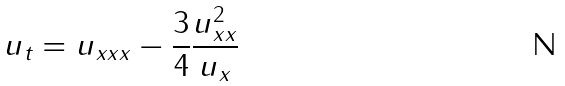Convert formula to latex. <formula><loc_0><loc_0><loc_500><loc_500>u _ { t } = u _ { x x x } - \frac { 3 } { 4 } \frac { u _ { x x } ^ { 2 } } { u _ { x } }</formula> 